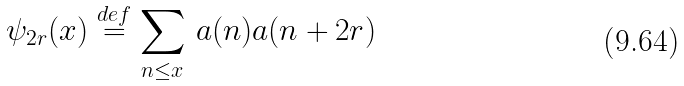Convert formula to latex. <formula><loc_0><loc_0><loc_500><loc_500>\psi _ { 2 r } ( x ) \stackrel { d e f } { = } \sum _ { n \leq x } \, \L a ( n ) \L a ( n + 2 r )</formula> 